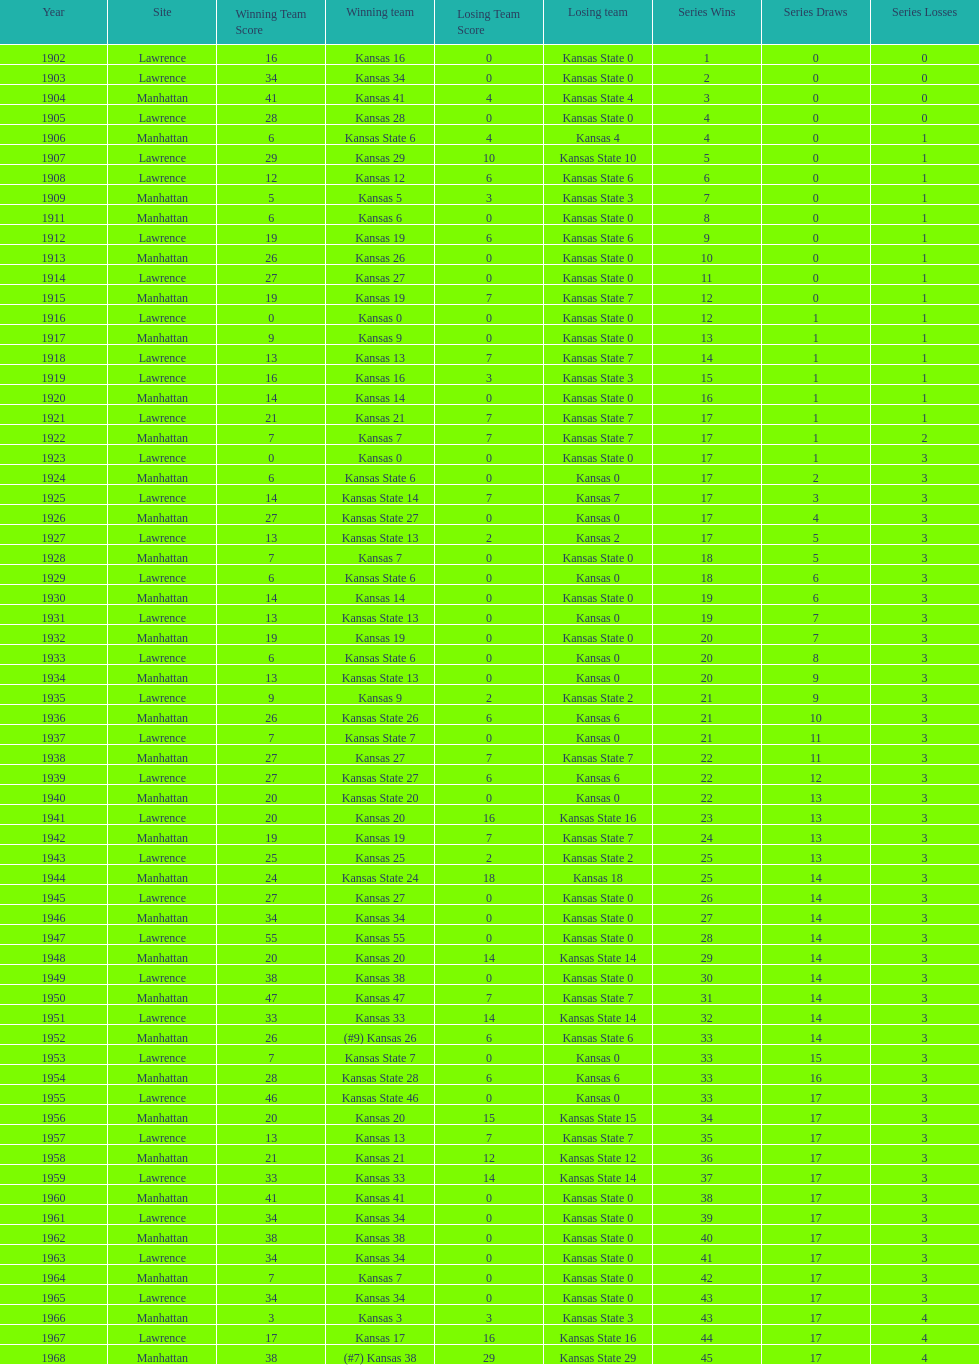Before 1950 what was the most points kansas scored? 55. 